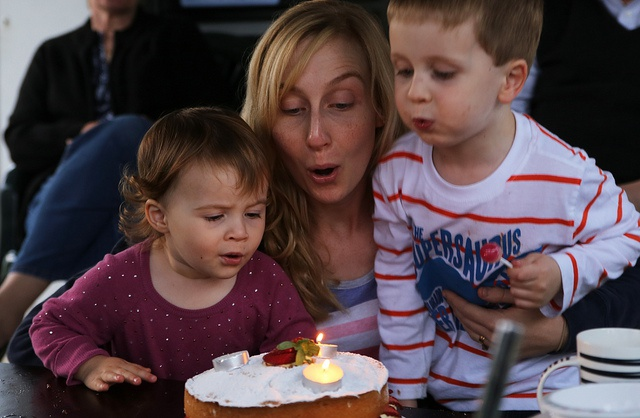Describe the objects in this image and their specific colors. I can see people in darkgray, gray, and black tones, people in darkgray, maroon, black, and brown tones, people in darkgray, black, maroon, and brown tones, people in darkgray, black, navy, and gray tones, and dining table in darkgray, black, lightgray, maroon, and gray tones in this image. 